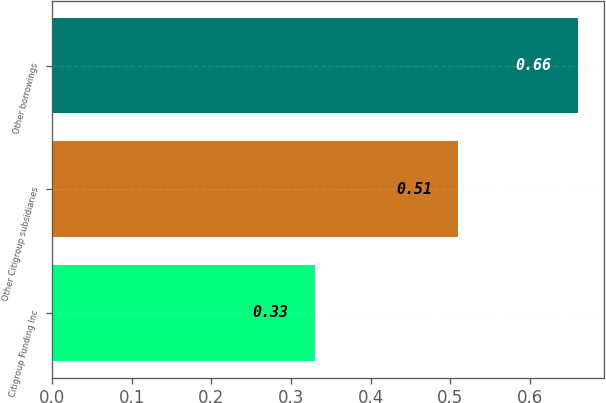<chart> <loc_0><loc_0><loc_500><loc_500><bar_chart><fcel>Citigroup Funding Inc<fcel>Other Citigroup subsidiaries<fcel>Other borrowings<nl><fcel>0.33<fcel>0.51<fcel>0.66<nl></chart> 